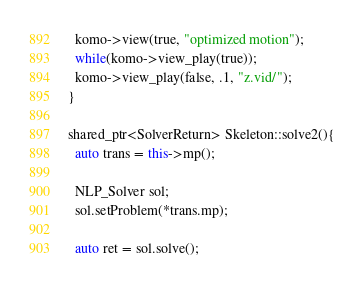Convert code to text. <code><loc_0><loc_0><loc_500><loc_500><_C++_>  komo->view(true, "optimized motion");
  while(komo->view_play(true));
  komo->view_play(false, .1, "z.vid/");
}

shared_ptr<SolverReturn> Skeleton::solve2(){
  auto trans = this->mp();

  NLP_Solver sol;
  sol.setProblem(*trans.mp);

  auto ret = sol.solve();</code> 